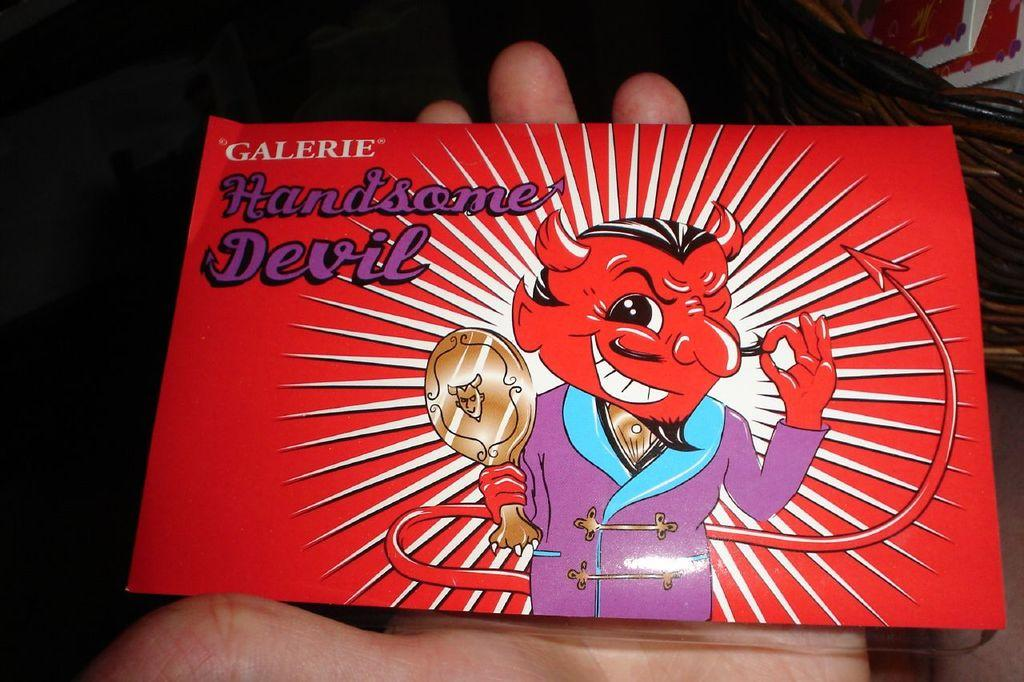What is the person holding in the image? There is a person's hand holding a card in the image. What can be seen on the card? The card contains a picture and some text. What is located on the right side of the image? There is a basket with objects on the right side of the image. What type of society is depicted in the image? There is no society depicted in the image; it features a person's hand holding a card with a picture and text, and a basket with objects on the right side. 